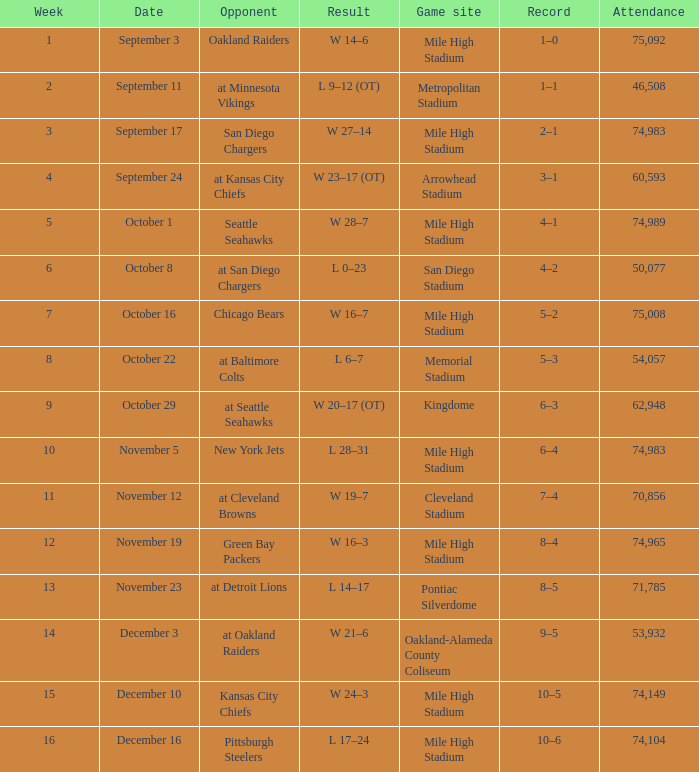On what date was the result w 28–7? October 1. 